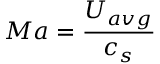<formula> <loc_0><loc_0><loc_500><loc_500>M a = \frac { U _ { a v g } } { c _ { s } }</formula> 